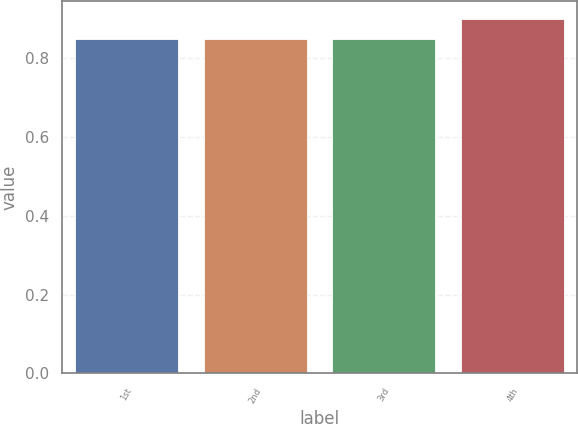Convert chart. <chart><loc_0><loc_0><loc_500><loc_500><bar_chart><fcel>1st<fcel>2nd<fcel>3rd<fcel>4th<nl><fcel>0.85<fcel>0.85<fcel>0.85<fcel>0.9<nl></chart> 